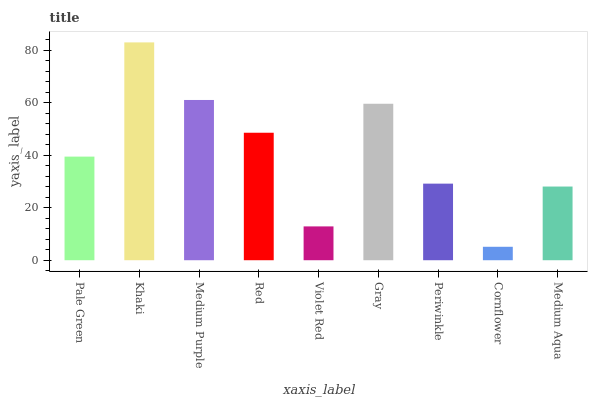Is Cornflower the minimum?
Answer yes or no. Yes. Is Khaki the maximum?
Answer yes or no. Yes. Is Medium Purple the minimum?
Answer yes or no. No. Is Medium Purple the maximum?
Answer yes or no. No. Is Khaki greater than Medium Purple?
Answer yes or no. Yes. Is Medium Purple less than Khaki?
Answer yes or no. Yes. Is Medium Purple greater than Khaki?
Answer yes or no. No. Is Khaki less than Medium Purple?
Answer yes or no. No. Is Pale Green the high median?
Answer yes or no. Yes. Is Pale Green the low median?
Answer yes or no. Yes. Is Gray the high median?
Answer yes or no. No. Is Periwinkle the low median?
Answer yes or no. No. 